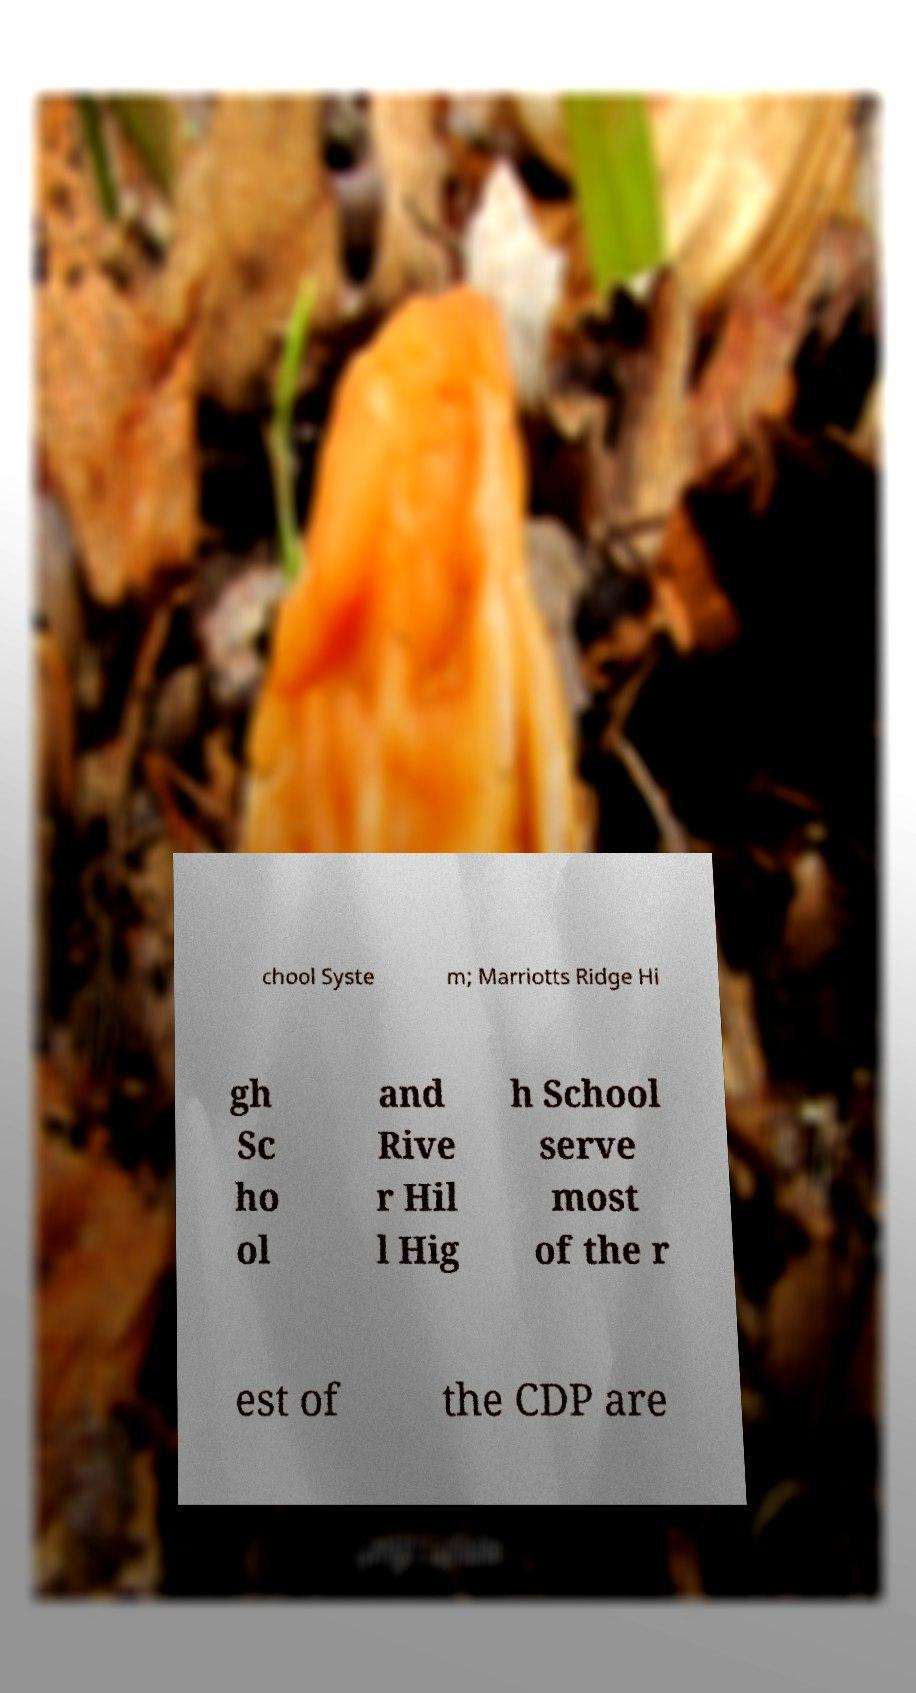I need the written content from this picture converted into text. Can you do that? chool Syste m; Marriotts Ridge Hi gh Sc ho ol and Rive r Hil l Hig h School serve most of the r est of the CDP are 